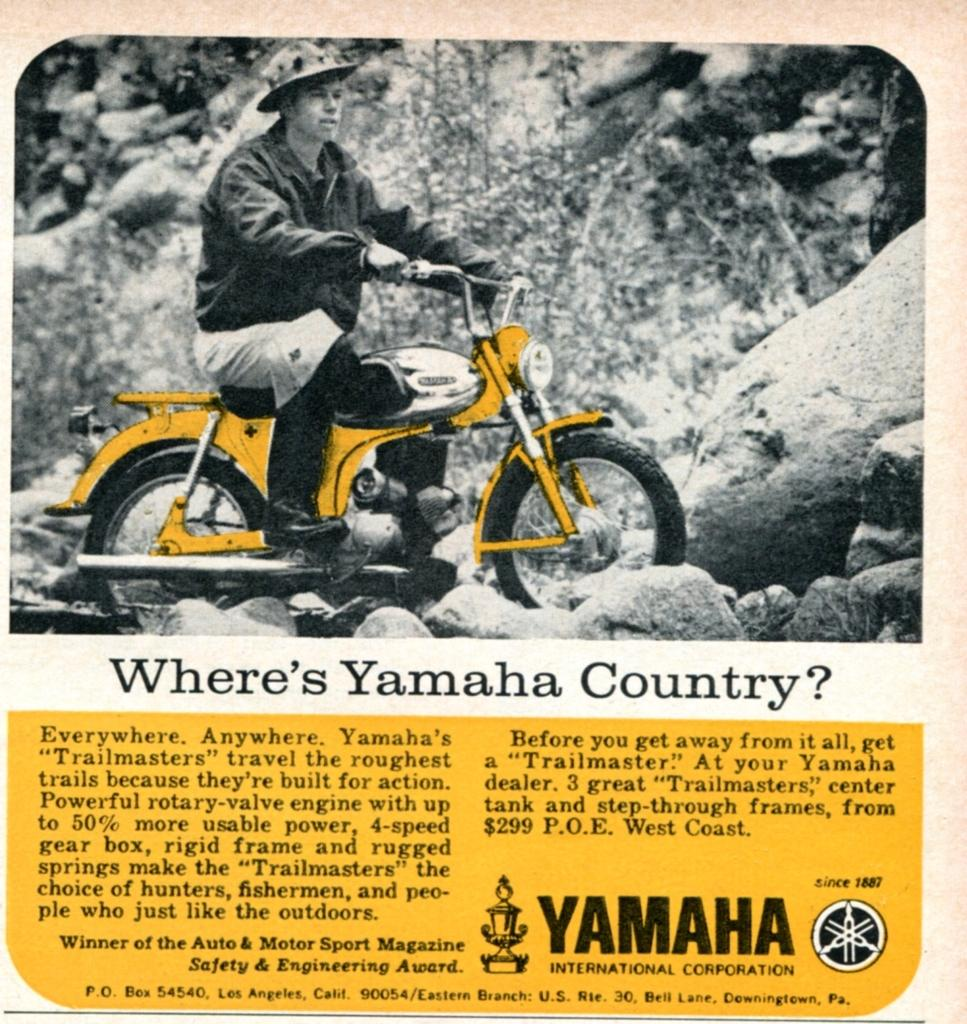What is the man in the image doing? The man is riding a bike in the image. What is the man wearing on his head? The man is wearing a hat in the image. What can be seen in the background of the image? There is a stone and a plant in the background of the image. How many coils can be seen on the bike in the image? There are no coils visible on the bike in the image. What type of kick is the man performing while riding the bike? The man is not performing any kick while riding the bike in the image. 